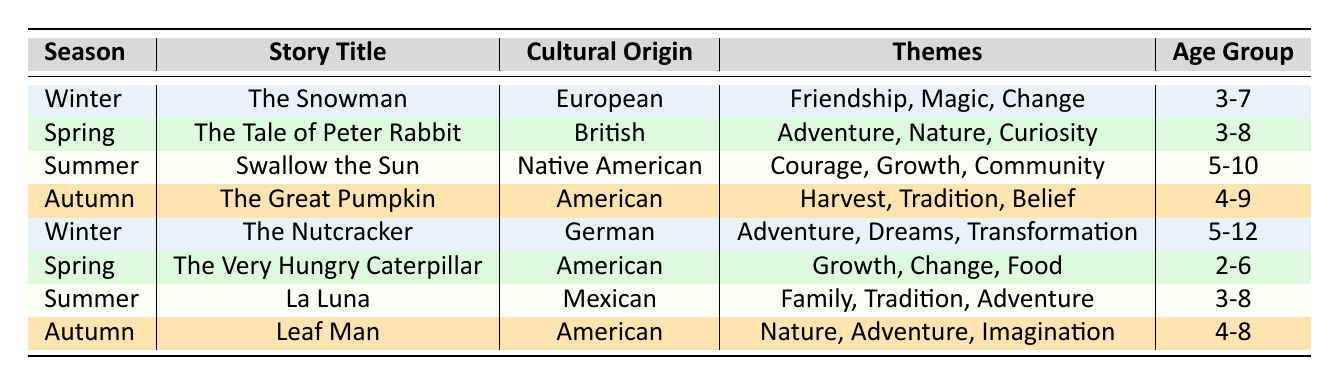What is the cultural origin of the story "The Nutcracker"? The table lists "The Nutcracker" under the Winter season with its cultural origin specified as "German".
Answer: German How many stories are categorized under the Spring season? By looking at the table, there are two stories listed under the Spring season: "The Tale of Peter Rabbit" and "The Very Hungry Caterpillar".
Answer: 2 Which story features themes of "Nature" and is suitable for kids ages 4-9? The table shows that "The Great Pumpkin" includes "Nature" as one of its themes and is suitable for ages 4-9.
Answer: The Great Pumpkin Is "La Luna" a story that emphasizes themes of "Courage"? The table indicates that "La Luna" has the themes "Family", "Tradition", and "Adventure", but does not include "Courage".
Answer: No What is the average age range of the stories listed for Summer? The age groups for Summer stories are 5-10 (Swallow the Sun) and 3-8 (La Luna). To find the average, we can calculate the midpoint of each age range: 5-10 gives an average of (5 + 10)/2 = 7.5, and 3-8 gives (3 + 8)/2 = 5.5. Then we sum these averages: (7.5 + 5.5) / 2 = 6.5.
Answer: 6.5 Which story from Winter has themes of "Adventure" and "Dreams"? Looking at the table, "The Nutcracker" is listed under Winter and has themes of "Adventure" and "Dreams".
Answer: The Nutcracker What themes are associated with "The Tale of Peter Rabbit"? The table specifies that "The Tale of Peter Rabbit" has the themes "Adventure", "Nature", and "Curiosity".
Answer: Adventure, Nature, Curiosity How many stories emphasize themes related to "Adventure"? We can see in the table that "The Nutcracker", "The Tale of Peter Rabbit", "La Luna", "Leaf Man", and "Swallow the Sun" all have "Adventure" as a theme. Counting them gives us five stories.
Answer: 5 